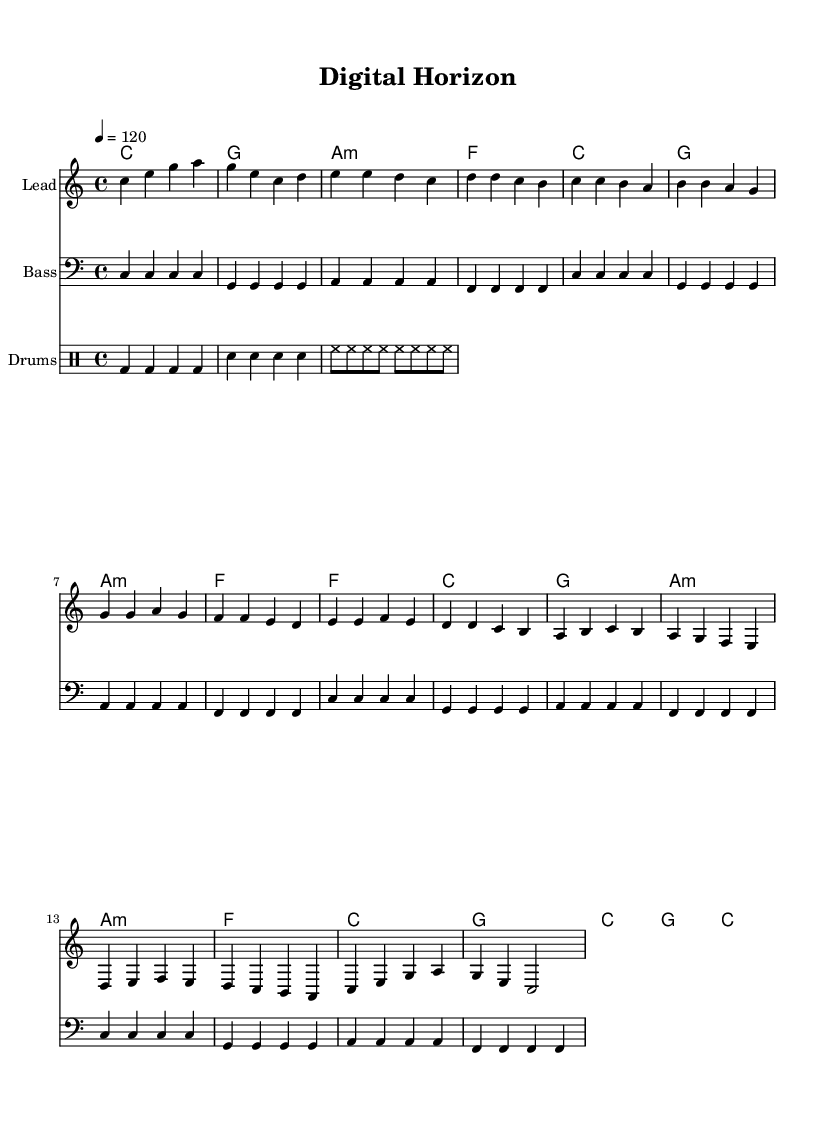What is the key signature of this music? The key signature is indicated at the beginning of the score and shows C major, which has no sharps or flats.
Answer: C major What is the time signature of this music? The time signature is located near the beginning of the score, which shows it is in 4/4 time.
Answer: 4/4 What is the tempo of the piece? The tempo marking is provided and indicates the speed of the piece, which is set to 120 beats per minute.
Answer: 120 How many measures are in the chorus section? The chorus consists of four lines in the score. Each line typically contains one measure, leading to a total of four measures for the chorus.
Answer: 4 What chord type is used for the first chord in the bridge? The first chord in the bridge is indicated as an A minor chord, which denotes the type.
Answer: A minor How many distinct sections does this piece have? The piece is structured into five distinct sections: Intro, Verse, Chorus, Bridge, and Outro. Counting these gives a total of five sections.
Answer: 5 Which instrument plays the melody? The score indicates that the melody is played on a staff labeled "Lead," which indicates the lead instrument for this part.
Answer: Lead 